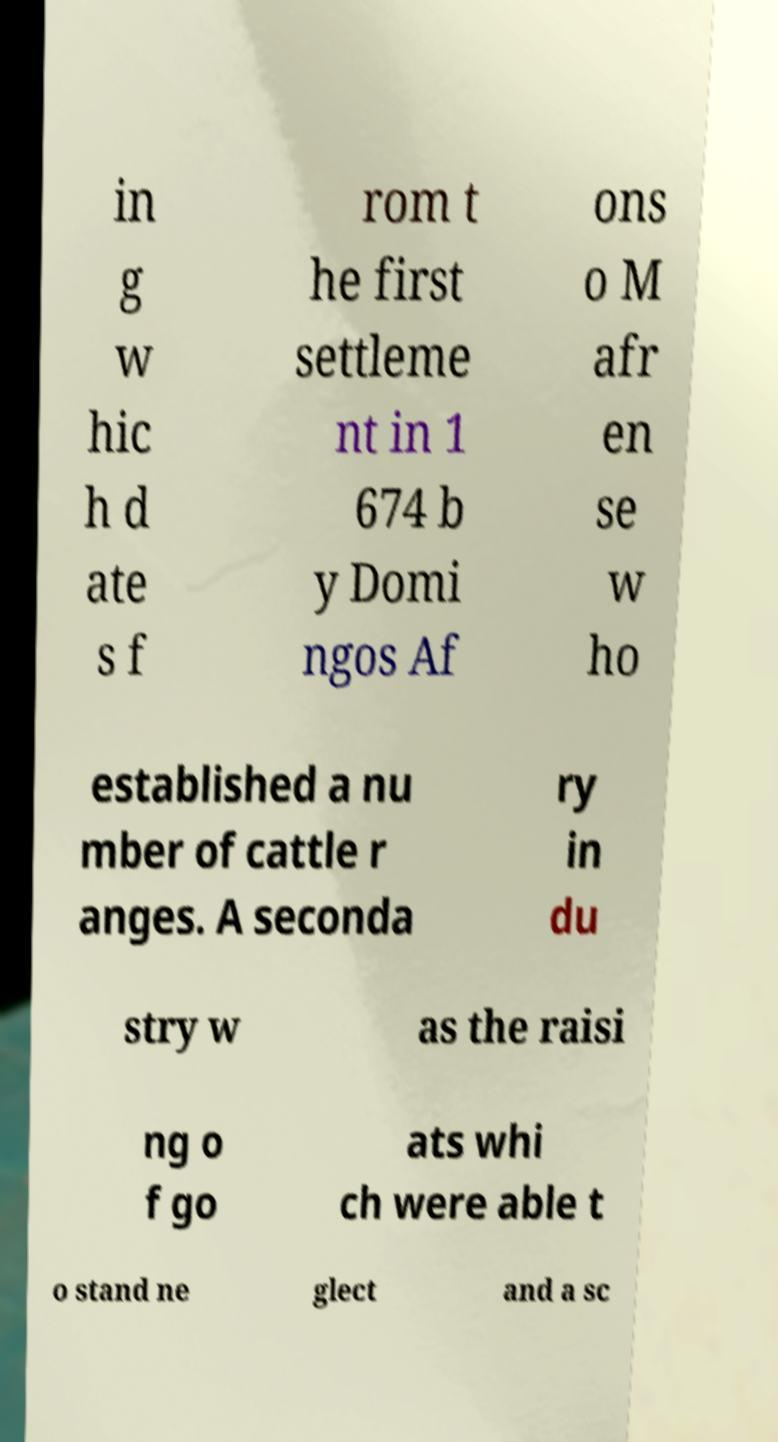Could you extract and type out the text from this image? in g w hic h d ate s f rom t he first settleme nt in 1 674 b y Domi ngos Af ons o M afr en se w ho established a nu mber of cattle r anges. A seconda ry in du stry w as the raisi ng o f go ats whi ch were able t o stand ne glect and a sc 